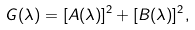<formula> <loc_0><loc_0><loc_500><loc_500>G ( \lambda ) = [ A ( \lambda ) ] ^ { 2 } + [ B ( \lambda ) ] ^ { 2 } ,</formula> 